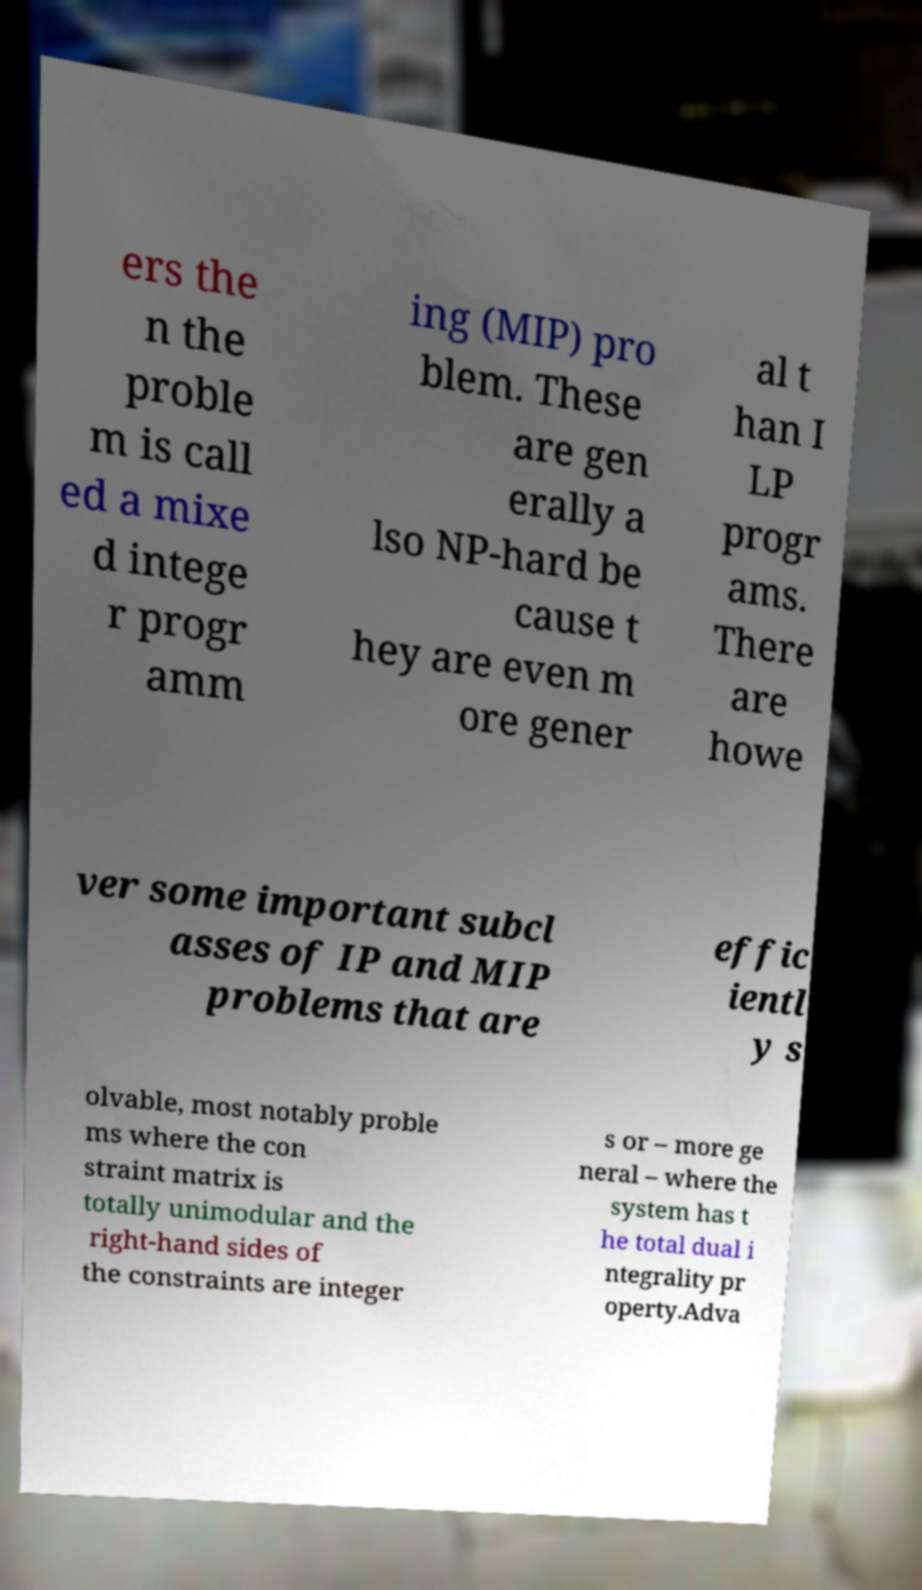What messages or text are displayed in this image? I need them in a readable, typed format. ers the n the proble m is call ed a mixe d intege r progr amm ing (MIP) pro blem. These are gen erally a lso NP-hard be cause t hey are even m ore gener al t han I LP progr ams. There are howe ver some important subcl asses of IP and MIP problems that are effic ientl y s olvable, most notably proble ms where the con straint matrix is totally unimodular and the right-hand sides of the constraints are integer s or – more ge neral – where the system has t he total dual i ntegrality pr operty.Adva 